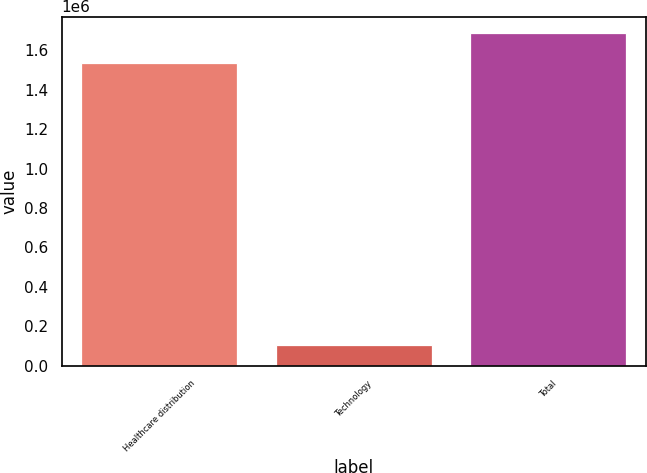Convert chart to OTSL. <chart><loc_0><loc_0><loc_500><loc_500><bar_chart><fcel>Healthcare distribution<fcel>Technology<fcel>Total<nl><fcel>1.53353e+06<fcel>106319<fcel>1.68688e+06<nl></chart> 